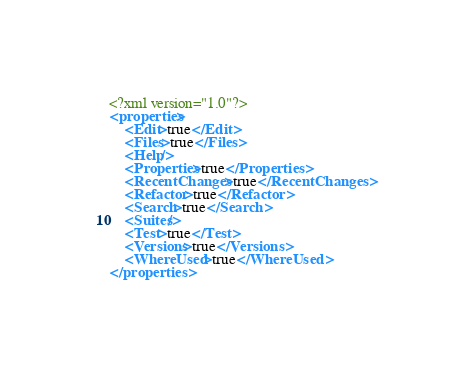<code> <loc_0><loc_0><loc_500><loc_500><_XML_><?xml version="1.0"?>
<properties>
	<Edit>true</Edit>
	<Files>true</Files>
	<Help/>
	<Properties>true</Properties>
	<RecentChanges>true</RecentChanges>
	<Refactor>true</Refactor>
	<Search>true</Search>
	<Suites/>
	<Test>true</Test>
	<Versions>true</Versions>
	<WhereUsed>true</WhereUsed>
</properties>
</code> 